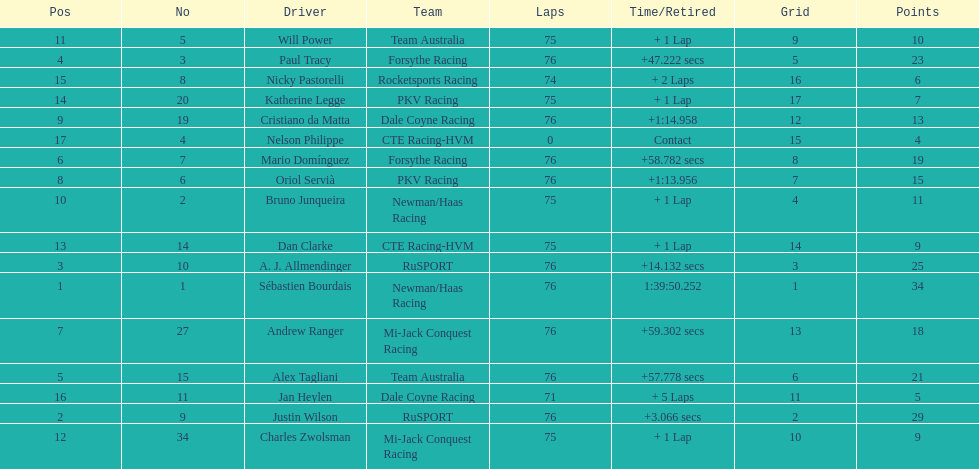How many positions are held by canada? 3. 